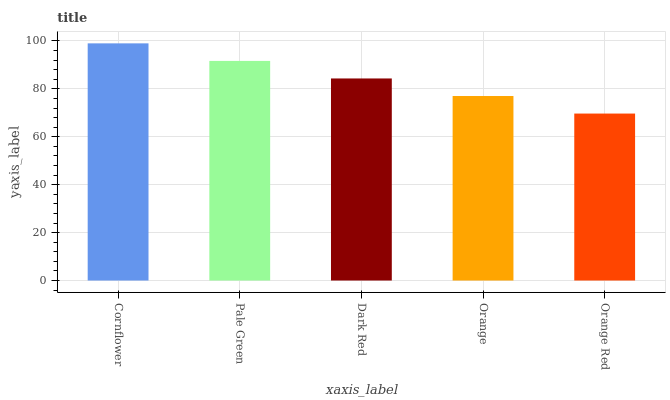Is Orange Red the minimum?
Answer yes or no. Yes. Is Cornflower the maximum?
Answer yes or no. Yes. Is Pale Green the minimum?
Answer yes or no. No. Is Pale Green the maximum?
Answer yes or no. No. Is Cornflower greater than Pale Green?
Answer yes or no. Yes. Is Pale Green less than Cornflower?
Answer yes or no. Yes. Is Pale Green greater than Cornflower?
Answer yes or no. No. Is Cornflower less than Pale Green?
Answer yes or no. No. Is Dark Red the high median?
Answer yes or no. Yes. Is Dark Red the low median?
Answer yes or no. Yes. Is Orange the high median?
Answer yes or no. No. Is Orange the low median?
Answer yes or no. No. 